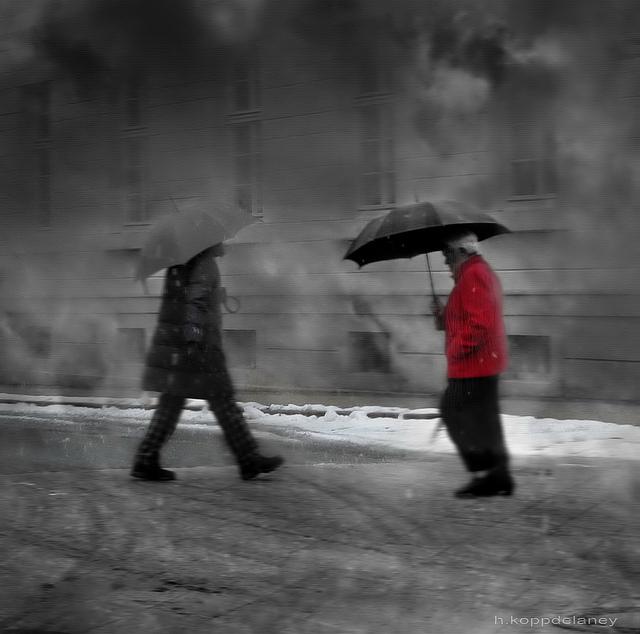Is the person doing a dangerous jump?
Answer briefly. No. How many people are here?
Give a very brief answer. 2. What color is the umbrella?
Write a very short answer. Black. Is this weather nasty and cold?
Concise answer only. Yes. Was this photo taken during the summertime?
Quick response, please. No. What is the primary color in the photo?
Be succinct. Gray. What is the one color shown here?
Give a very brief answer. Red. What is in the mans right hand?
Give a very brief answer. Umbrella. Is her umbrella blowing away?
Write a very short answer. No. What weather condition is it outside?
Short answer required. Rainy. 